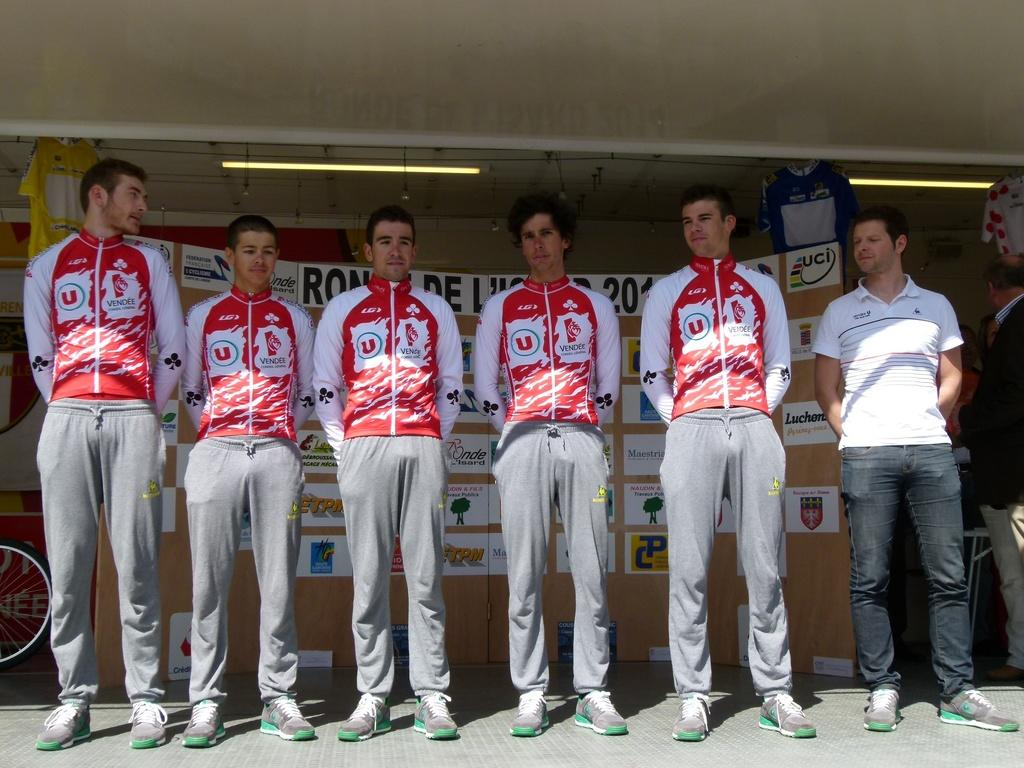Provide a one-sentence caption for the provided image. A line up of men in red and white and the word vendee on their tops. 